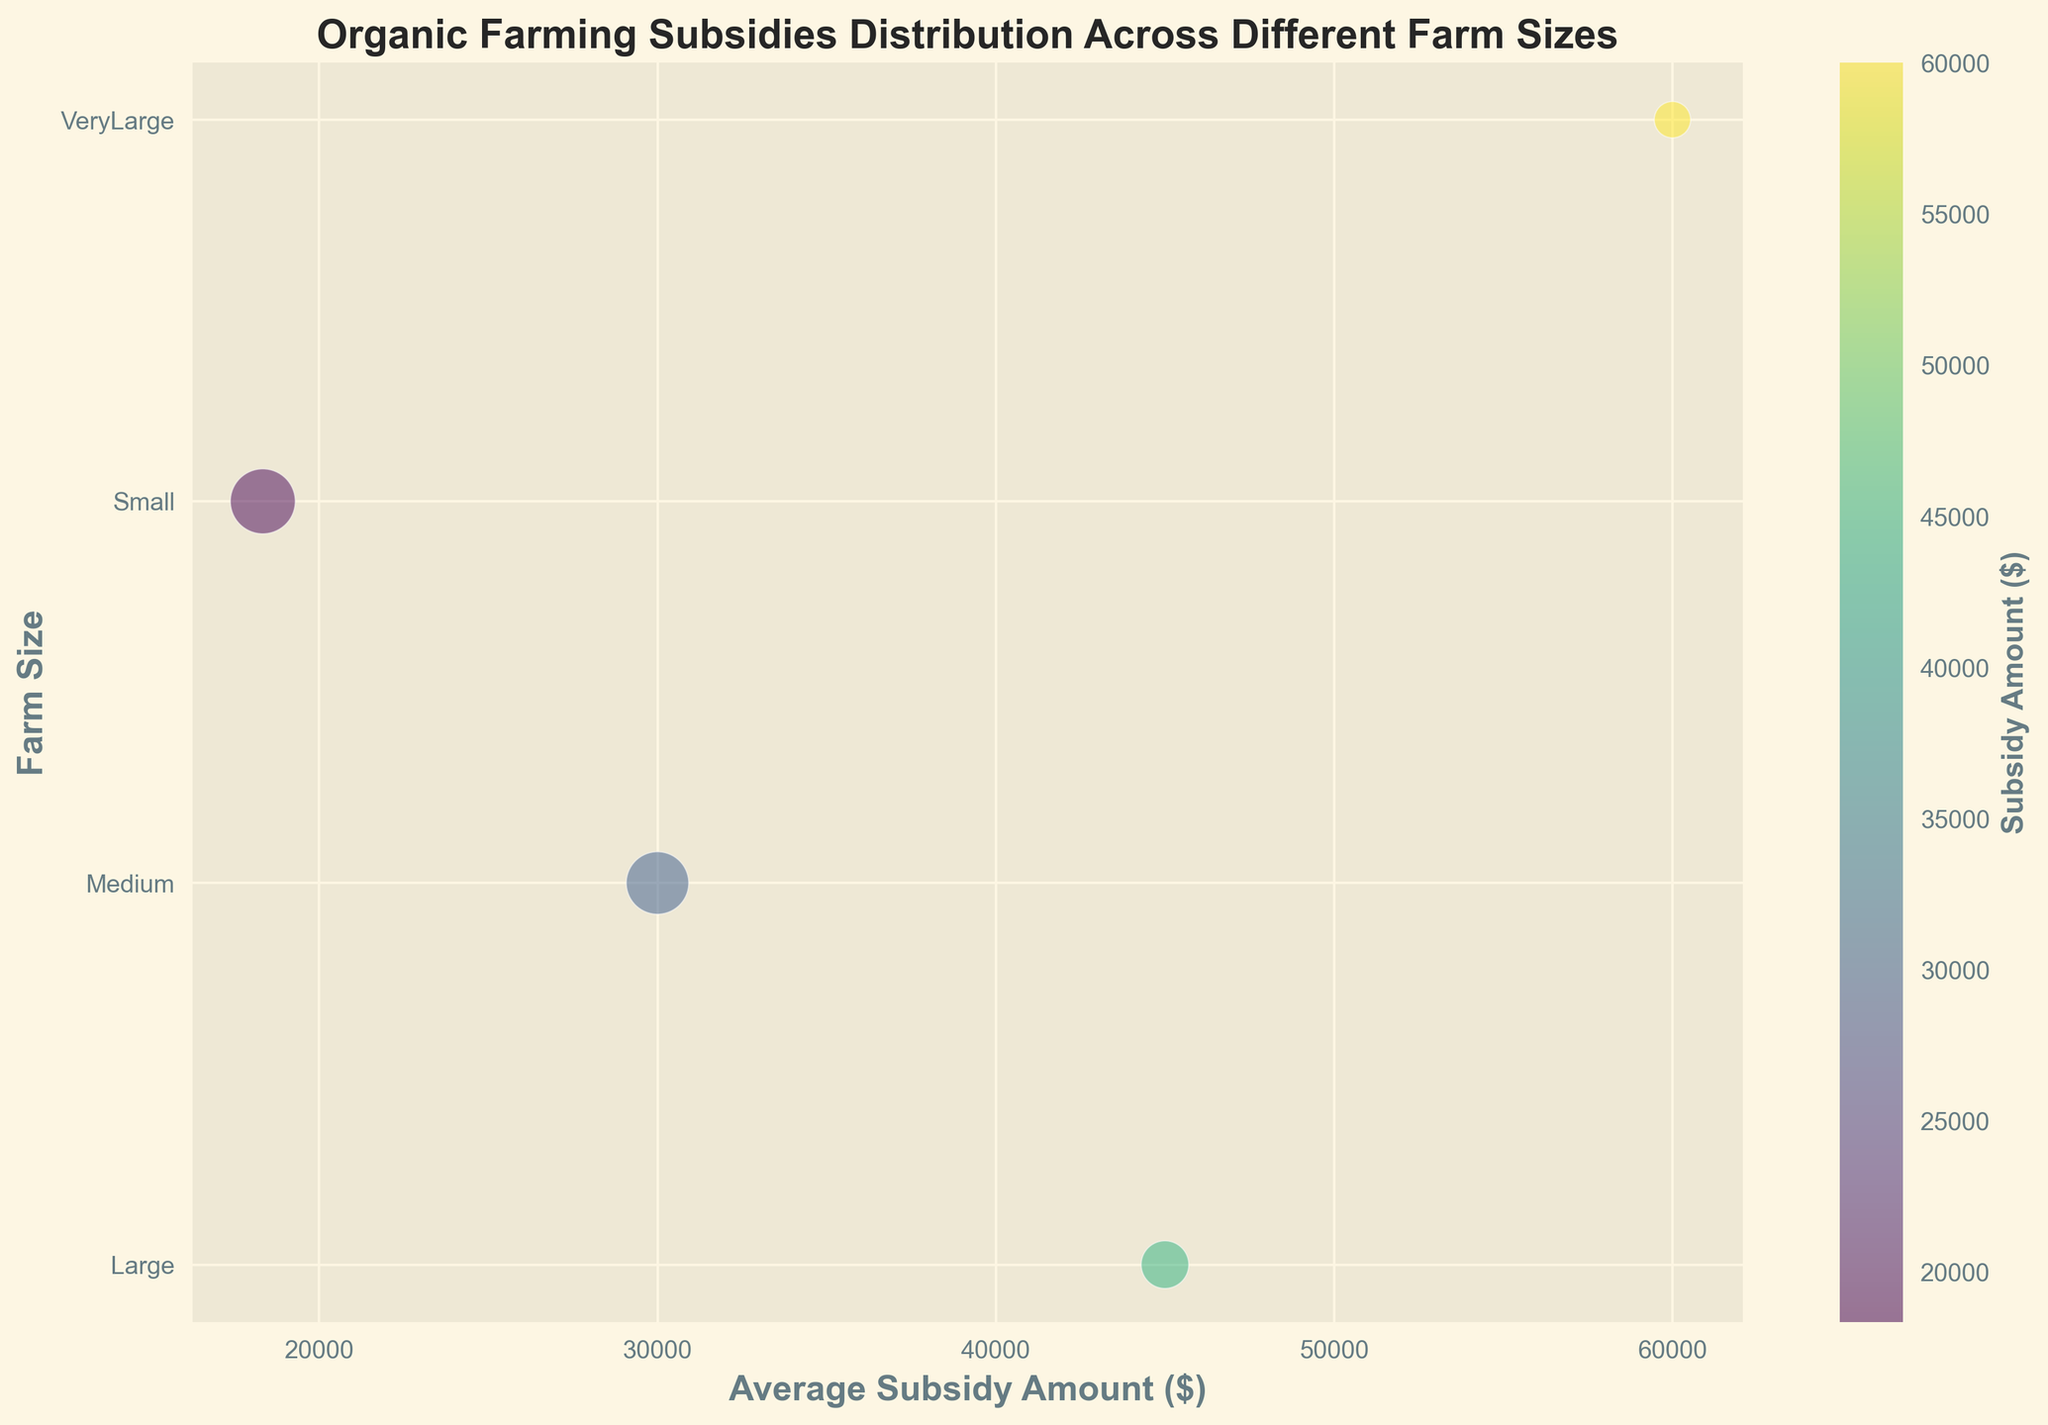Which farm size receives the highest average subsidy amount? By looking at the y-axis (farm sizes) and corresponding x-axis (average subsidy amounts), the bubble at the highest position represents VeryLarge farms with an average subsidy amount of around $60,000.
Answer: VeryLarge Which farm size has the largest number of farms represented by the bubble size? The size of the bubble indicates the number of farms. The largest bubble is associated with Small farms.
Answer: Small How does the average subsidy amount change as the farm size increases from Small to VeryLarge? As we move from Small to VeryLarge farms on the y-axis, the bubbles' x-axis values (average subsidy amounts) consistently increase.
Answer: Increases Which farm size receives the smallest average subsidy amount? By looking at the y-axis (farm sizes) and corresponding x-axis (average subsidy amount), the bubble at the lowest position represents Small farms with an average subsidy amount around $18,000.
Answer: Small Compare the number of Medium farms to the number of VeryLarge farms. Which category has more? The bubble size corresponding to Medium farms is significantly larger than the bubble for VeryLarge farms, indicating more Medium farms.
Answer: Medium Do large farms receive more subsidies on average than medium farms? The average subsidy amount for Large farms is between $40,000 and $50,000 shown on the x-axis, which is higher than the $25,000 to $35,000 for Medium farms.
Answer: Yes Which farm size has the highest variability in subsidy amounts? The color intensity indicates the subsidy amount variation. Small and Medium farms show greater variation in colors (green to yellow), suggesting higher variability, while VeryLarge has consistent intense yellow.
Answer: Small and Medium What’s the total study represented by the bubbles for Large farms? For Large farms, sum the values provided (100 + 120 + 140) = 360 farms.
Answer: 360 Compare the bubble sizes for Medium and Large farm sizes. Which has a more significant total number of farms? Medium farms have a larger bubble size compared to Large farms, indicating more farms in the Medium category.
Answer: Medium How does the color difference between Small and VeryLarge farms indicate the subsidy distribution? The lighter to darker shades of color in the bubble chart represent subsidy amounts. Small farms show gradient color ranging (indicating variation), while VeryLarge bubbles have consistent intense yellow, indicating less variation in subsidy amounts.
Answer: Small-Varied, VeryLarge-Consistent 